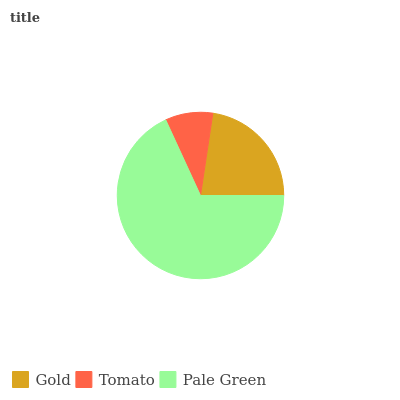Is Tomato the minimum?
Answer yes or no. Yes. Is Pale Green the maximum?
Answer yes or no. Yes. Is Pale Green the minimum?
Answer yes or no. No. Is Tomato the maximum?
Answer yes or no. No. Is Pale Green greater than Tomato?
Answer yes or no. Yes. Is Tomato less than Pale Green?
Answer yes or no. Yes. Is Tomato greater than Pale Green?
Answer yes or no. No. Is Pale Green less than Tomato?
Answer yes or no. No. Is Gold the high median?
Answer yes or no. Yes. Is Gold the low median?
Answer yes or no. Yes. Is Tomato the high median?
Answer yes or no. No. Is Pale Green the low median?
Answer yes or no. No. 